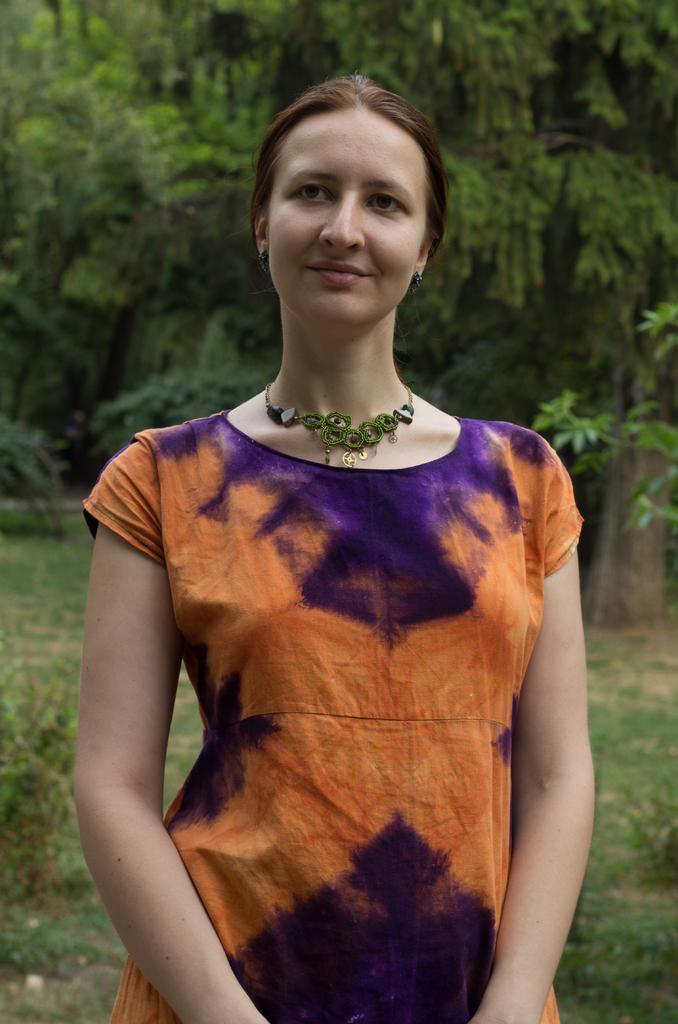Can you describe this image briefly? In the center of the image we can see a lady standing and smiling. In the background there are trees. At the bottom there is grass. 